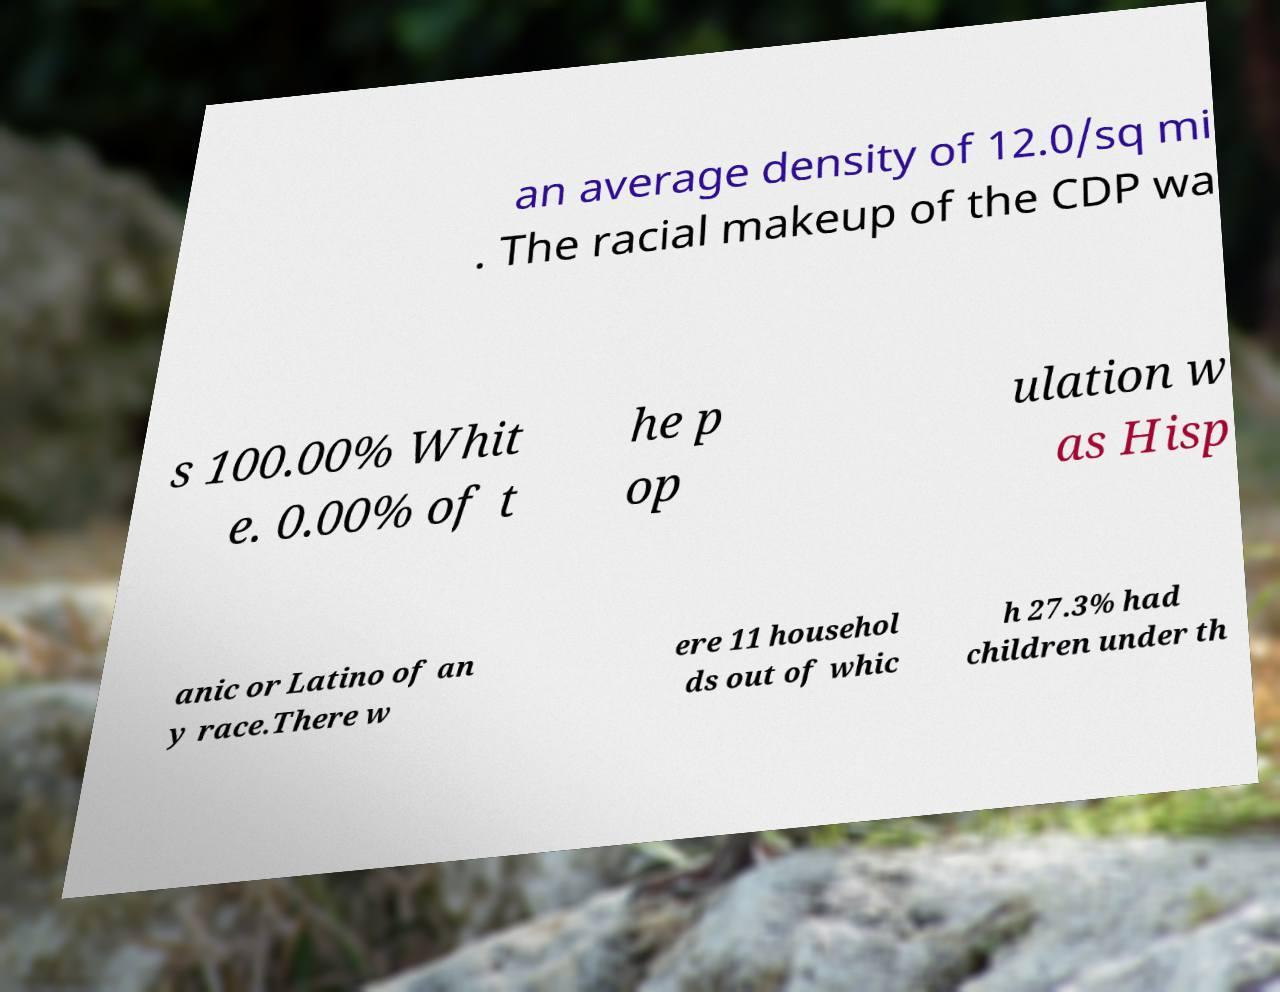I need the written content from this picture converted into text. Can you do that? an average density of 12.0/sq mi . The racial makeup of the CDP wa s 100.00% Whit e. 0.00% of t he p op ulation w as Hisp anic or Latino of an y race.There w ere 11 househol ds out of whic h 27.3% had children under th 